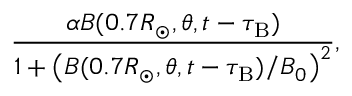Convert formula to latex. <formula><loc_0><loc_0><loc_500><loc_500>\frac { \alpha { B } ( 0 . 7 R _ { \odot } , \theta , t - \tau _ { B } ) } { 1 + \left ( { { B } ( 0 . 7 R _ { \odot } , \theta , t - \tau _ { B } ) } / { B _ { 0 } } \right ) ^ { 2 } } ,</formula> 